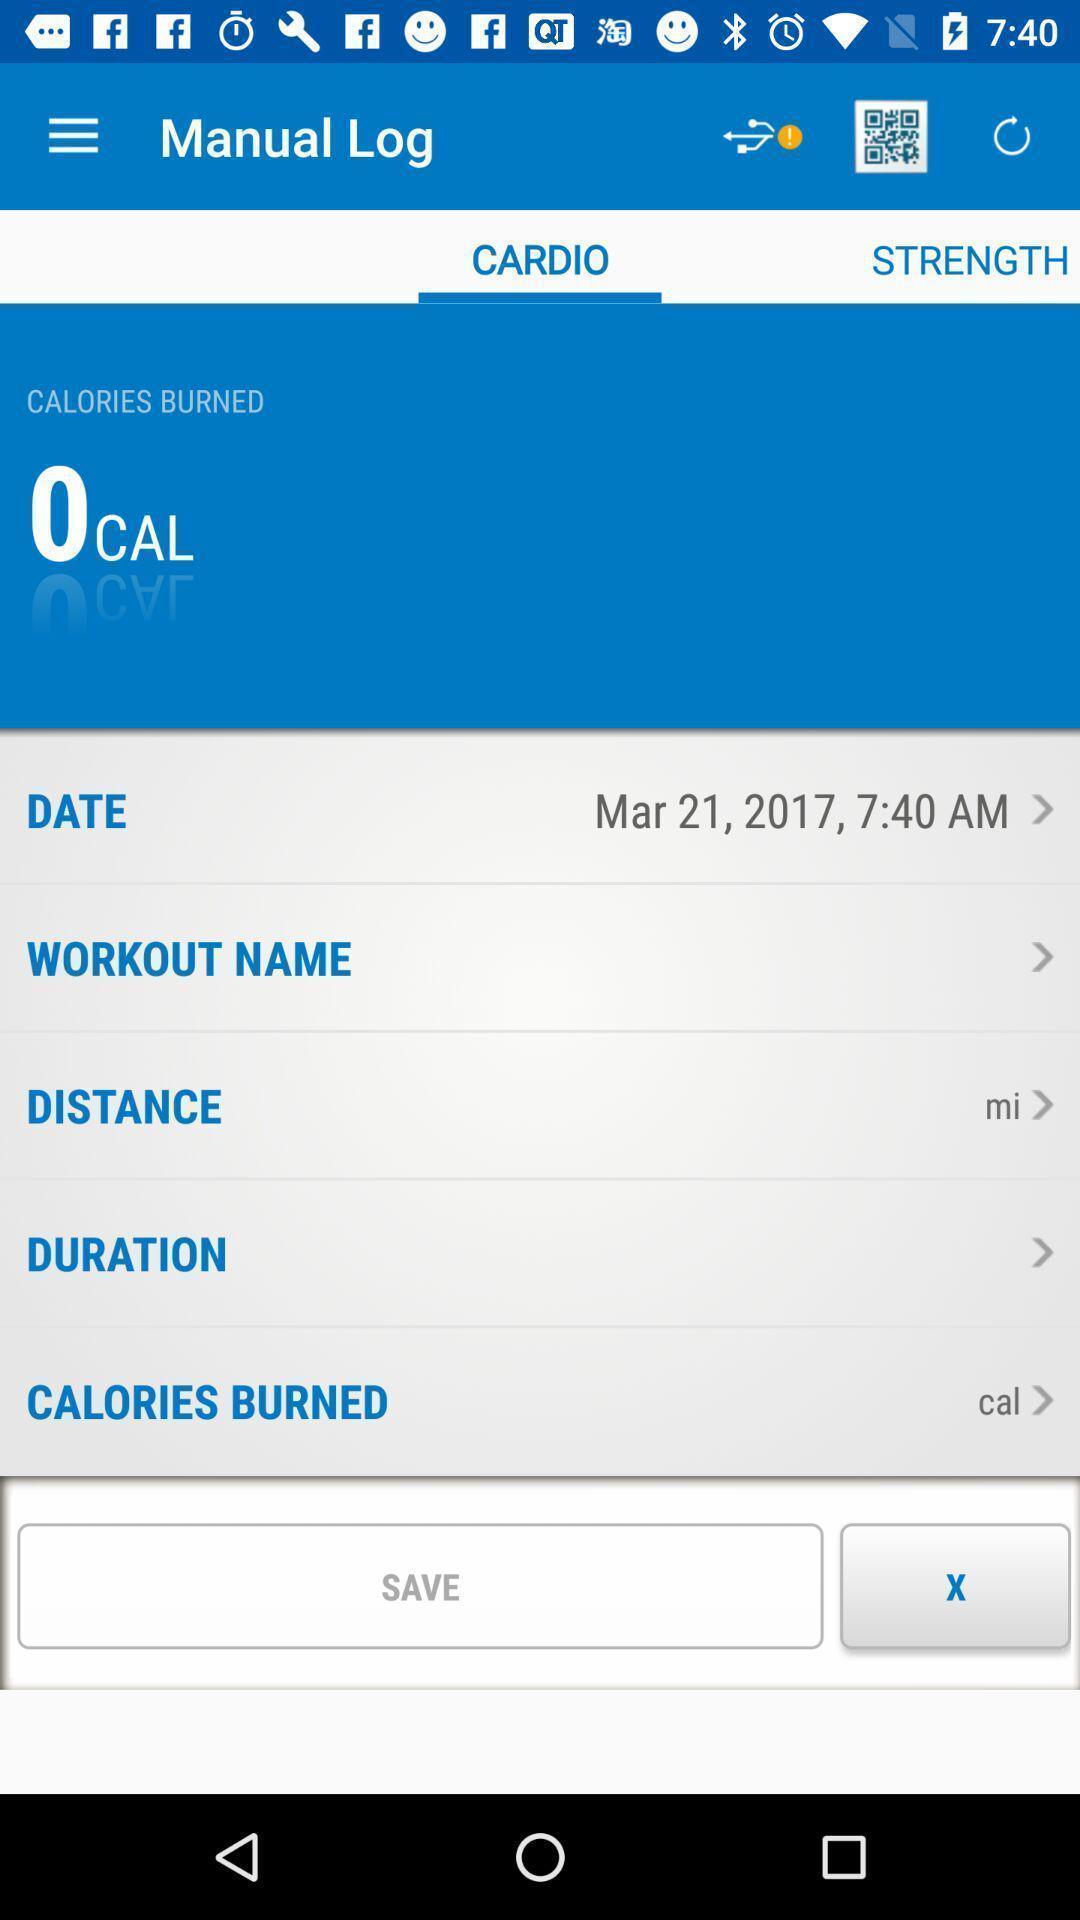What is the overall content of this screenshot? Screen page of a fitness tracker application. 